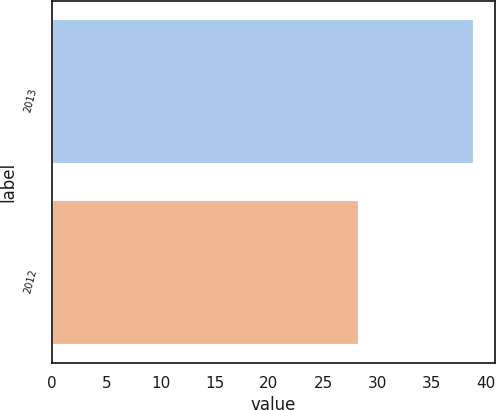<chart> <loc_0><loc_0><loc_500><loc_500><bar_chart><fcel>2013<fcel>2012<nl><fcel>38.87<fcel>28.33<nl></chart> 